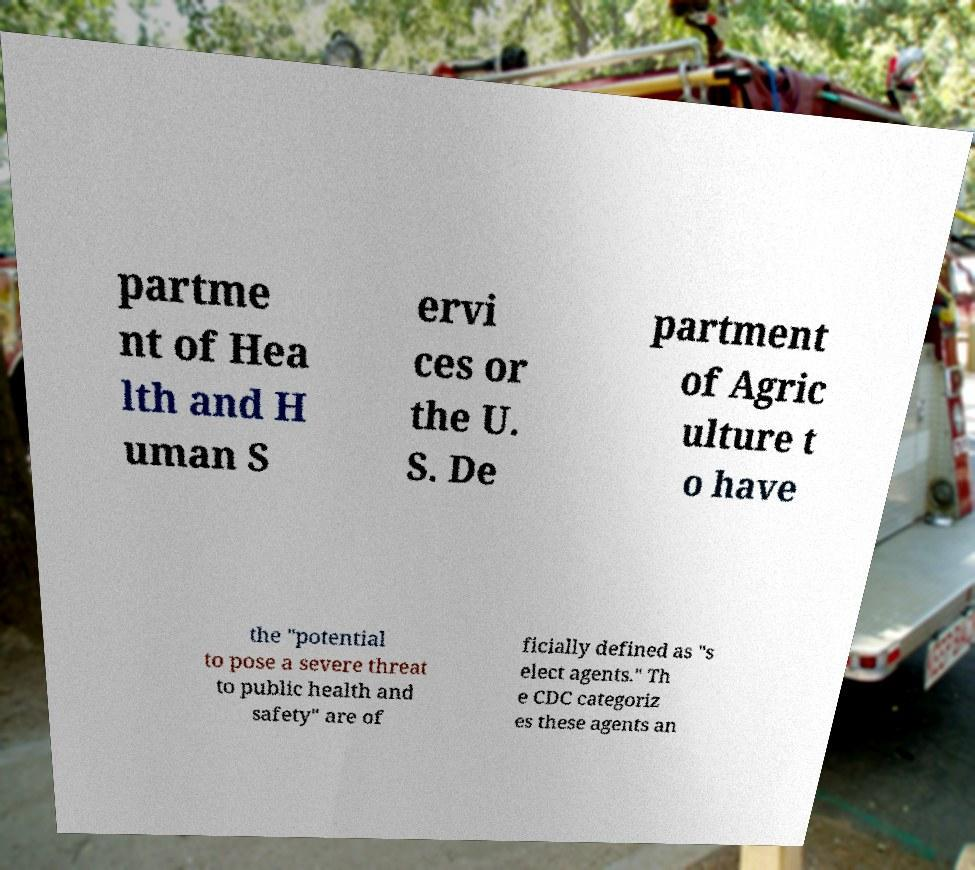Can you read and provide the text displayed in the image?This photo seems to have some interesting text. Can you extract and type it out for me? partme nt of Hea lth and H uman S ervi ces or the U. S. De partment of Agric ulture t o have the "potential to pose a severe threat to public health and safety" are of ficially defined as "s elect agents." Th e CDC categoriz es these agents an 